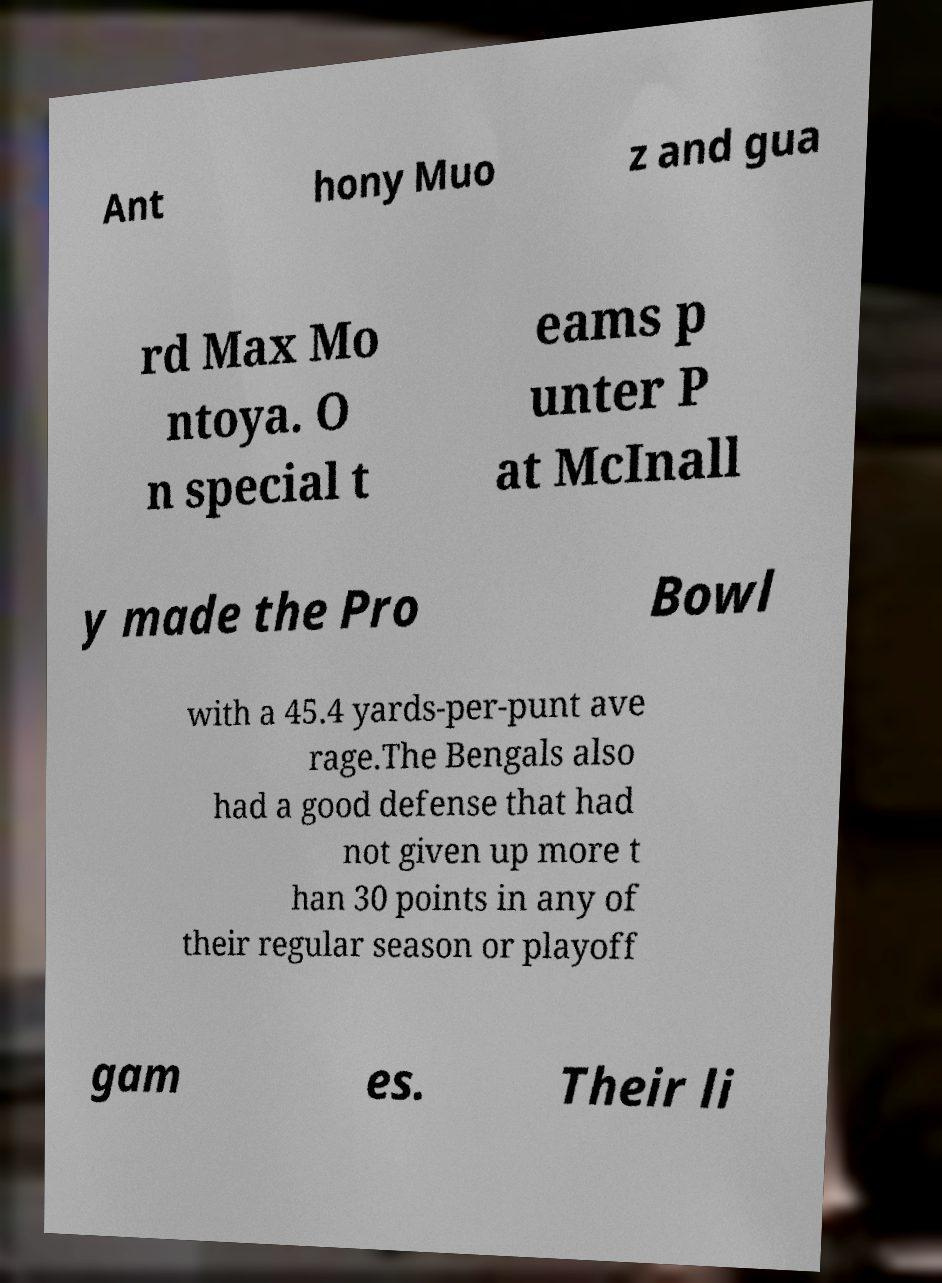What messages or text are displayed in this image? I need them in a readable, typed format. Ant hony Muo z and gua rd Max Mo ntoya. O n special t eams p unter P at McInall y made the Pro Bowl with a 45.4 yards-per-punt ave rage.The Bengals also had a good defense that had not given up more t han 30 points in any of their regular season or playoff gam es. Their li 